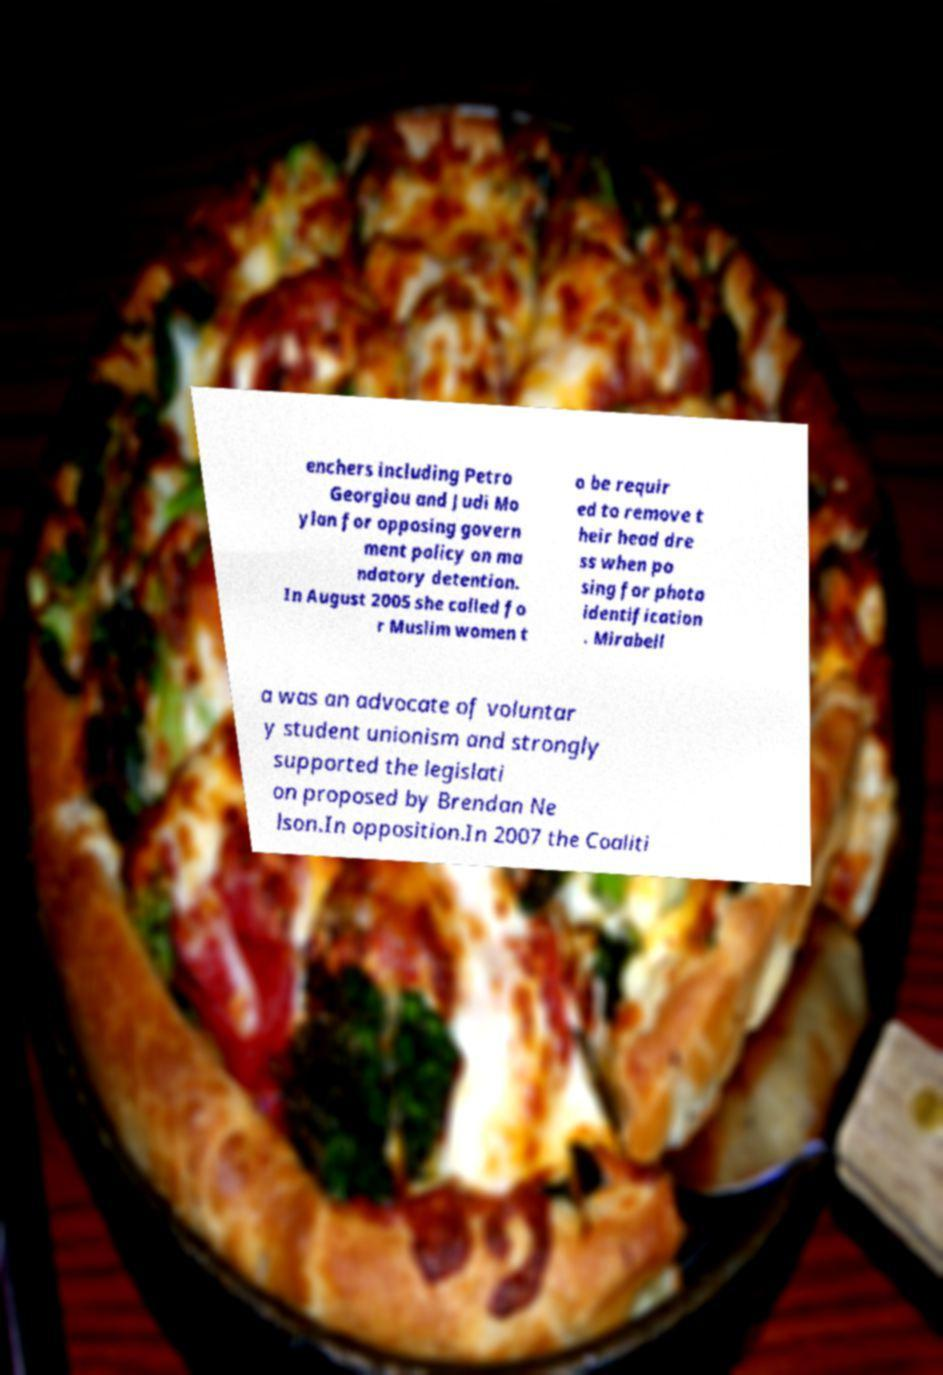What messages or text are displayed in this image? I need them in a readable, typed format. enchers including Petro Georgiou and Judi Mo ylan for opposing govern ment policy on ma ndatory detention. In August 2005 she called fo r Muslim women t o be requir ed to remove t heir head dre ss when po sing for photo identification . Mirabell a was an advocate of voluntar y student unionism and strongly supported the legislati on proposed by Brendan Ne lson.In opposition.In 2007 the Coaliti 